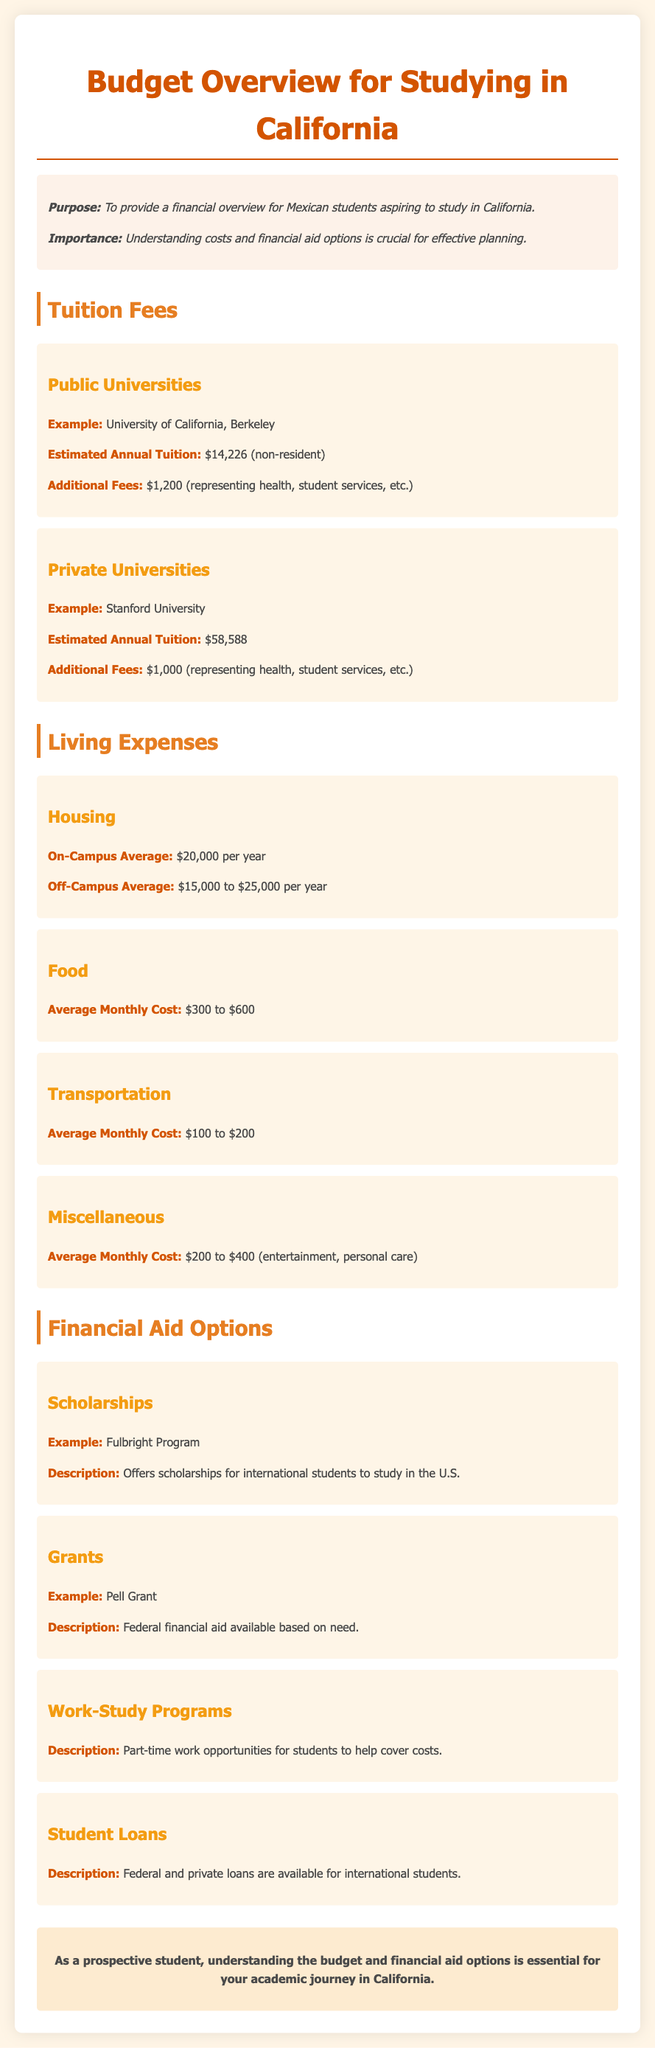What is the estimated annual tuition for the University of California, Berkeley? The document states that the estimated annual tuition for the University of California, Berkeley is $14,226 for non-residents.
Answer: $14,226 What is the additional fee for private universities like Stanford University? The document mentions that the additional fee for private universities, specifically Stanford University, is $1,000.
Answer: $1,000 What is the average monthly cost for food? According to the document, the average monthly cost for food ranges from $300 to $600.
Answer: $300 to $600 What scholarship program is mentioned in the financial aid options? The document highlights the Fulbright Program as an example of a scholarship for international students.
Answer: Fulbright Program What is the average cost range for off-campus housing? The document states that the average cost for off-campus housing ranges from $15,000 to $25,000 per year.
Answer: $15,000 to $25,000 How much can students expect to earn from work-study programs? The document does not provide specific earning amounts but mentions work-study programs offer part-time work opportunities to help cover costs.
Answer: Not specified What financial aid option is available based on need? The document describes the Pell Grant as federal financial aid available based on need.
Answer: Pell Grant What are the estimated annual tuition fees for private universities? The document indicates that the estimated annual tuition for private universities, using Stanford University as an example, is $58,588.
Answer: $58,588 